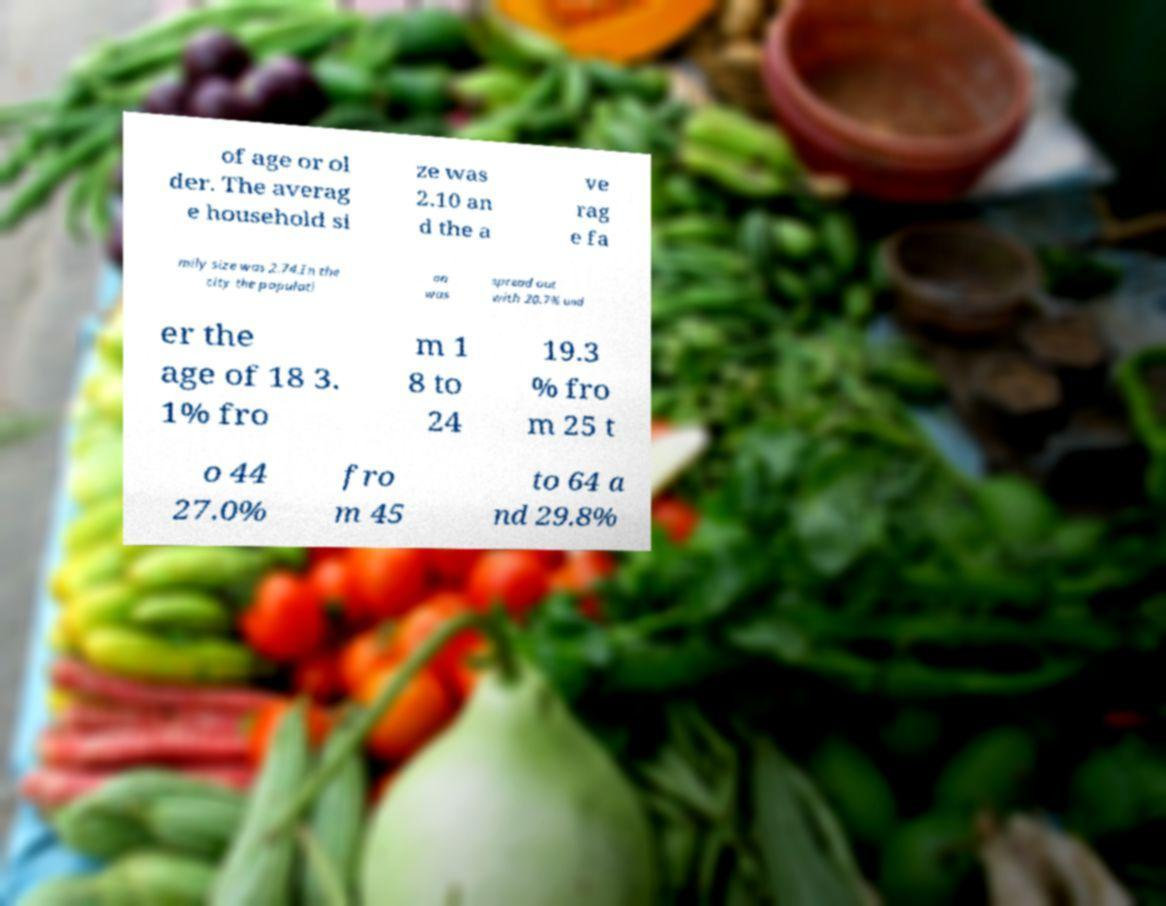Can you read and provide the text displayed in the image?This photo seems to have some interesting text. Can you extract and type it out for me? of age or ol der. The averag e household si ze was 2.10 an d the a ve rag e fa mily size was 2.74.In the city the populati on was spread out with 20.7% und er the age of 18 3. 1% fro m 1 8 to 24 19.3 % fro m 25 t o 44 27.0% fro m 45 to 64 a nd 29.8% 